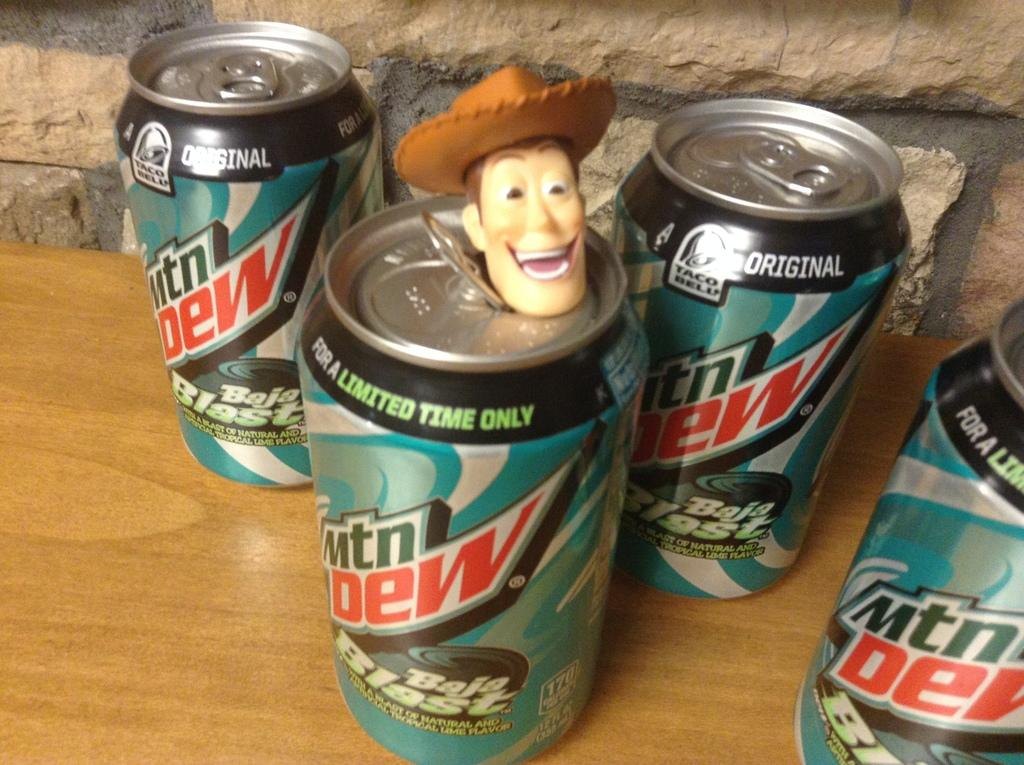Provide a one-sentence caption for the provided image. 4 botles of mtn dew brand new sit on the counter. 